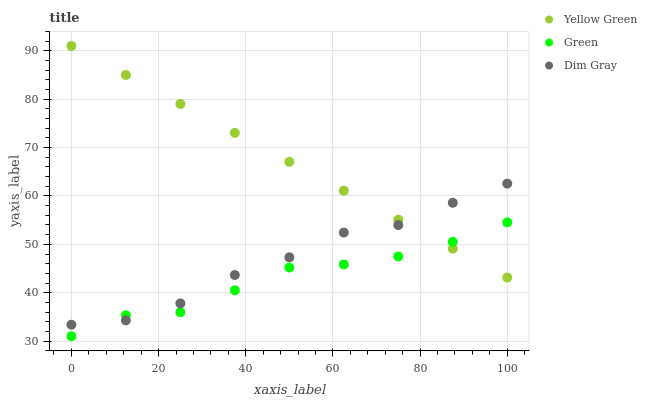Does Green have the minimum area under the curve?
Answer yes or no. Yes. Does Yellow Green have the maximum area under the curve?
Answer yes or no. Yes. Does Yellow Green have the minimum area under the curve?
Answer yes or no. No. Does Green have the maximum area under the curve?
Answer yes or no. No. Is Yellow Green the smoothest?
Answer yes or no. Yes. Is Dim Gray the roughest?
Answer yes or no. Yes. Is Green the smoothest?
Answer yes or no. No. Is Green the roughest?
Answer yes or no. No. Does Green have the lowest value?
Answer yes or no. Yes. Does Yellow Green have the lowest value?
Answer yes or no. No. Does Yellow Green have the highest value?
Answer yes or no. Yes. Does Green have the highest value?
Answer yes or no. No. Does Green intersect Yellow Green?
Answer yes or no. Yes. Is Green less than Yellow Green?
Answer yes or no. No. Is Green greater than Yellow Green?
Answer yes or no. No. 